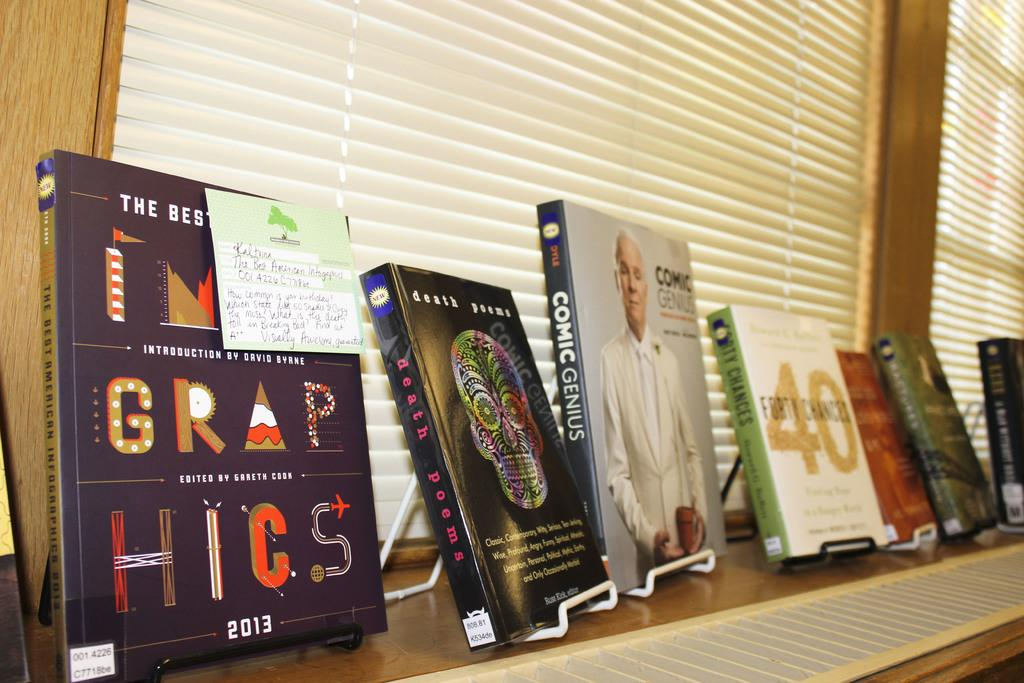<image>
Share a concise interpretation of the image provided. Books are lined up on stands in front of a window, one of which is Comic Genius. 